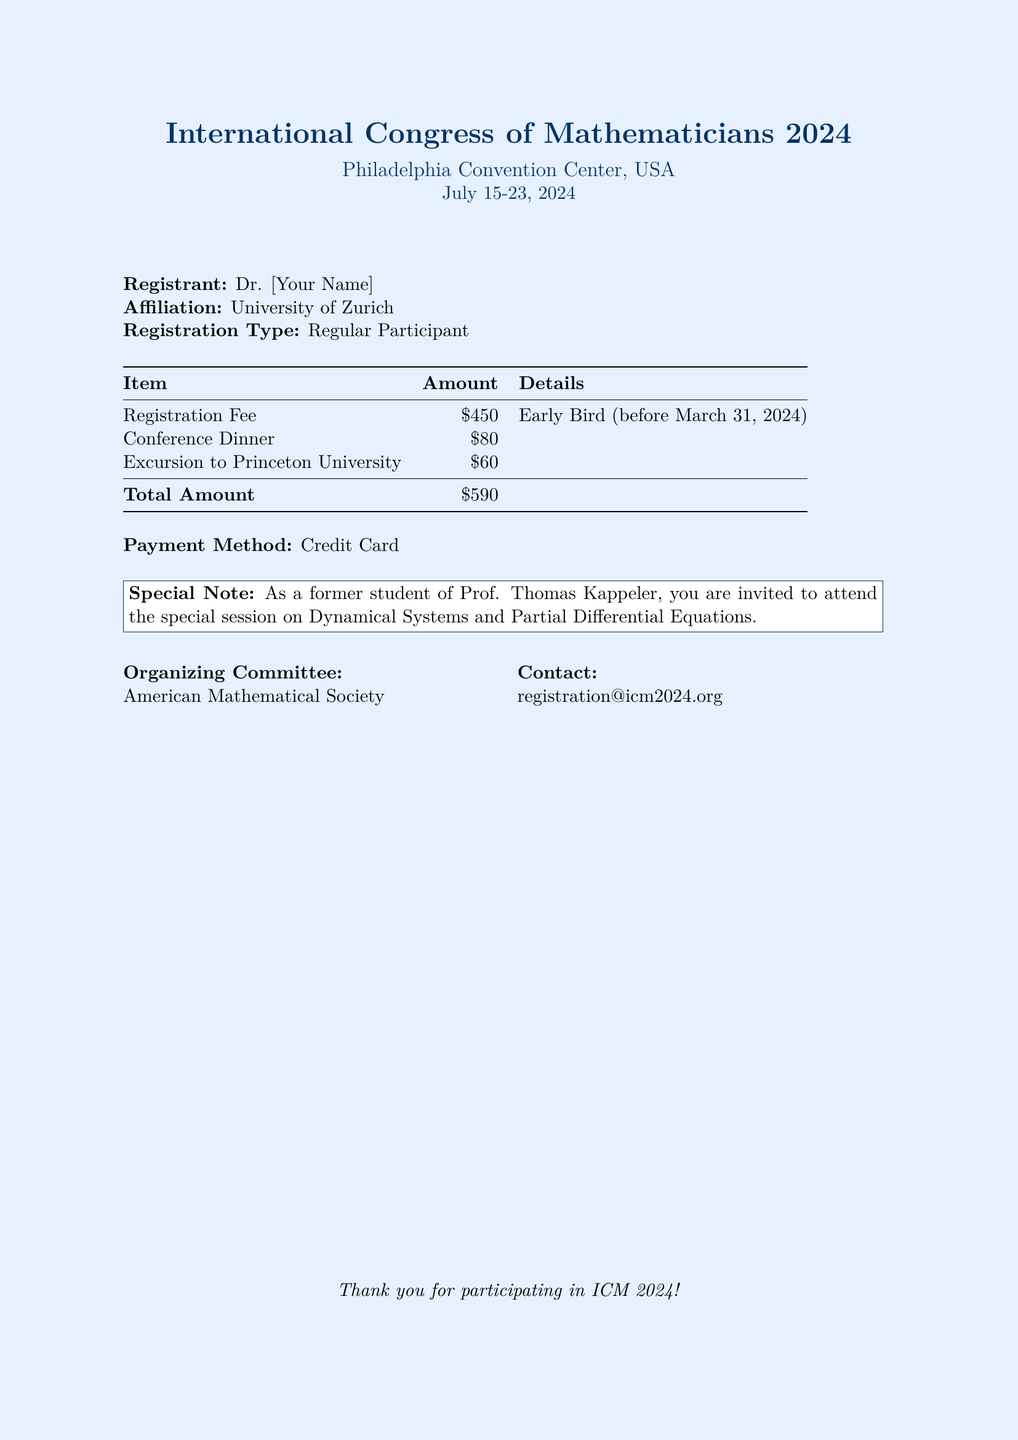What is the registration fee for early bird registration? The document specifies the registration fee under the early bird category is $450, which is listed in the fees table.
Answer: $450 What is the total amount due? The total amount is the sum of the registration fee, dinner, and excursion, which totals $590 as stated at the bottom of the fee table.
Answer: $590 What is the date by which the early bird registration fee must be paid? The document mentions that the early bird registration fee is valid before March 31, 2024, indicating the deadline for this fee type.
Answer: March 31, 2024 What event is the special note referring to? The special note invites the registrant to attend the special session on Dynamical Systems and Partial Differential Equations, according to the information provided in the note section.
Answer: special session on Dynamical Systems and Partial Differential Equations Who is the organizing committee of the event? The document identifies the American Mathematical Society as the organizing committee of the International Congress of Mathematicians in 2024.
Answer: American Mathematical Society What is the payment method indicated in the document? The document explicitly states that the payment method for the registration fee is through a credit card.
Answer: Credit Card What is the location of the congress? The document clearly states that the congress will take place at the Philadelphia Convention Center in the USA.
Answer: Philadelphia Convention Center, USA What are the dates of the conference? The document specifies the dates of the conference as July 15-23, 2024, which is mentioned prominently at the beginning.
Answer: July 15-23, 2024 